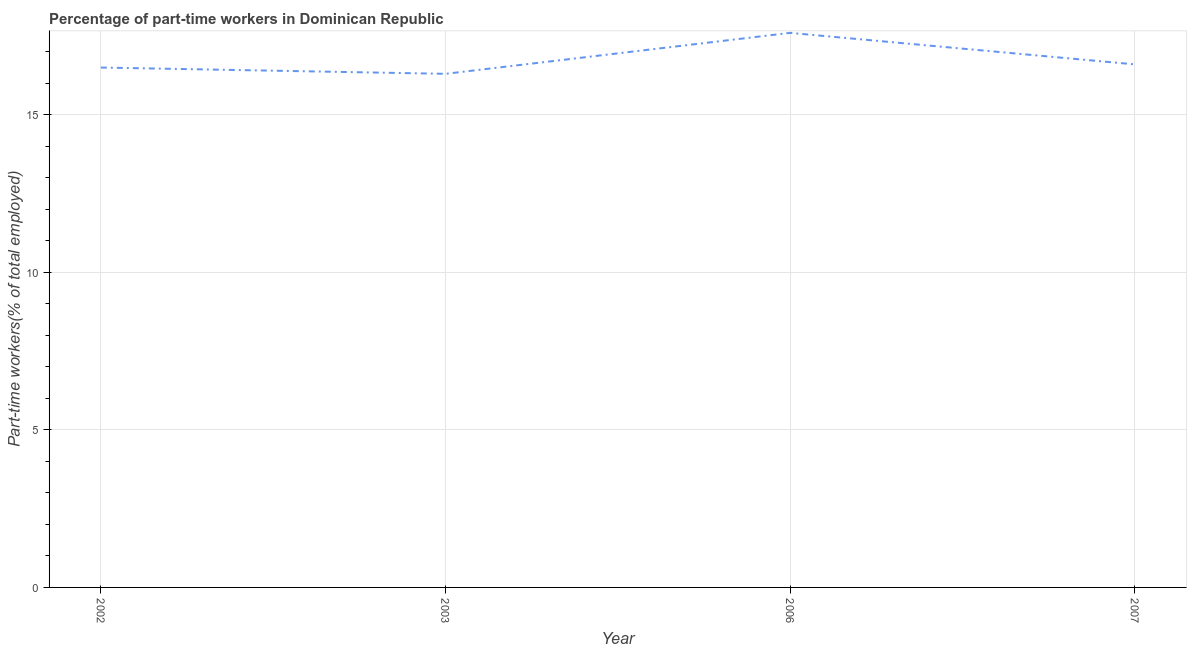What is the percentage of part-time workers in 2002?
Ensure brevity in your answer.  16.5. Across all years, what is the maximum percentage of part-time workers?
Offer a very short reply. 17.6. Across all years, what is the minimum percentage of part-time workers?
Keep it short and to the point. 16.3. In which year was the percentage of part-time workers minimum?
Keep it short and to the point. 2003. What is the sum of the percentage of part-time workers?
Keep it short and to the point. 67. What is the difference between the percentage of part-time workers in 2003 and 2006?
Your answer should be compact. -1.3. What is the average percentage of part-time workers per year?
Provide a short and direct response. 16.75. What is the median percentage of part-time workers?
Your answer should be very brief. 16.55. What is the ratio of the percentage of part-time workers in 2006 to that in 2007?
Offer a very short reply. 1.06. Is the difference between the percentage of part-time workers in 2002 and 2003 greater than the difference between any two years?
Provide a short and direct response. No. What is the difference between the highest and the lowest percentage of part-time workers?
Your answer should be compact. 1.3. How many lines are there?
Provide a short and direct response. 1. How many years are there in the graph?
Offer a terse response. 4. What is the title of the graph?
Offer a terse response. Percentage of part-time workers in Dominican Republic. What is the label or title of the X-axis?
Offer a terse response. Year. What is the label or title of the Y-axis?
Your answer should be very brief. Part-time workers(% of total employed). What is the Part-time workers(% of total employed) of 2003?
Your answer should be compact. 16.3. What is the Part-time workers(% of total employed) in 2006?
Your answer should be very brief. 17.6. What is the Part-time workers(% of total employed) in 2007?
Make the answer very short. 16.6. What is the difference between the Part-time workers(% of total employed) in 2003 and 2006?
Your answer should be very brief. -1.3. What is the difference between the Part-time workers(% of total employed) in 2006 and 2007?
Provide a succinct answer. 1. What is the ratio of the Part-time workers(% of total employed) in 2002 to that in 2003?
Offer a terse response. 1.01. What is the ratio of the Part-time workers(% of total employed) in 2002 to that in 2006?
Ensure brevity in your answer.  0.94. What is the ratio of the Part-time workers(% of total employed) in 2002 to that in 2007?
Offer a terse response. 0.99. What is the ratio of the Part-time workers(% of total employed) in 2003 to that in 2006?
Keep it short and to the point. 0.93. What is the ratio of the Part-time workers(% of total employed) in 2003 to that in 2007?
Keep it short and to the point. 0.98. What is the ratio of the Part-time workers(% of total employed) in 2006 to that in 2007?
Your answer should be very brief. 1.06. 